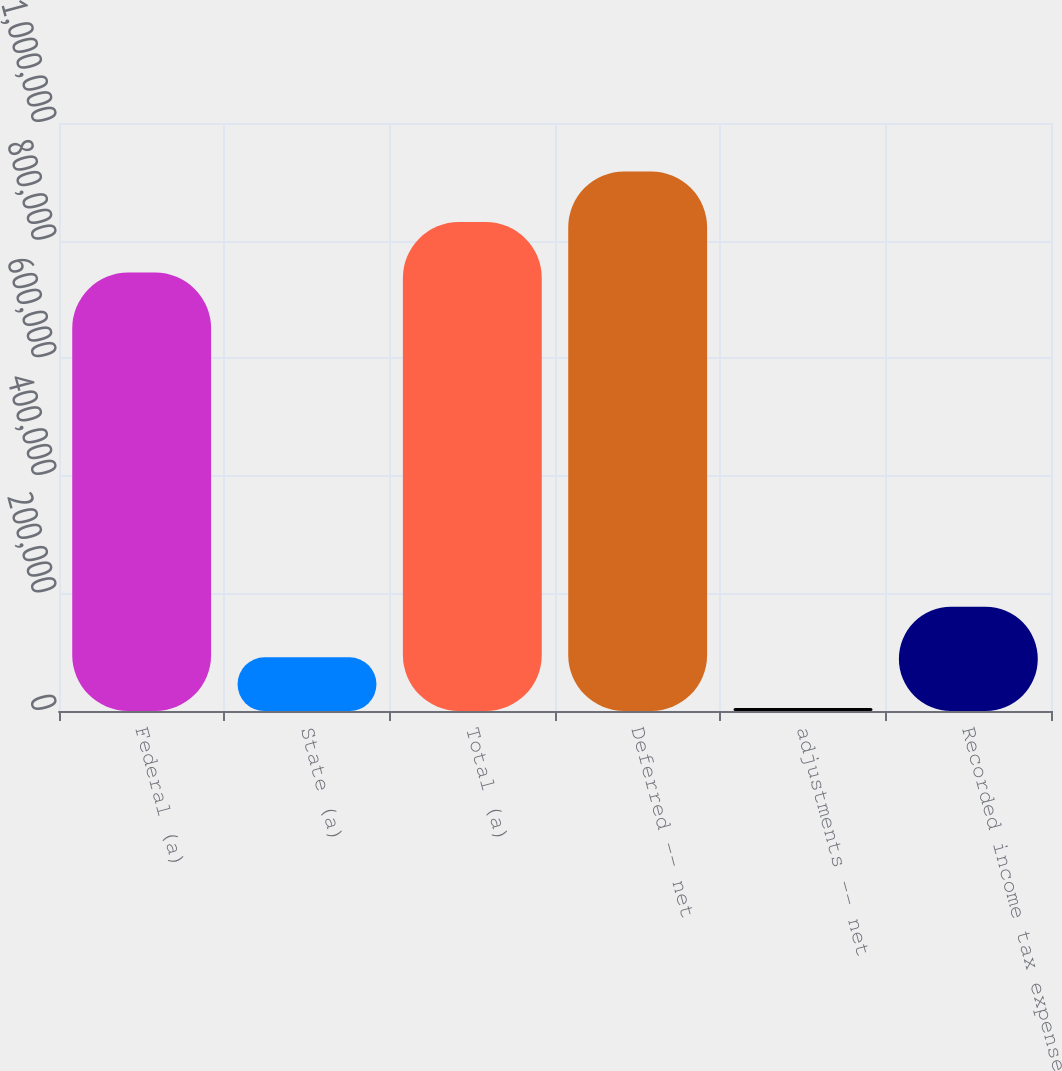<chart> <loc_0><loc_0><loc_500><loc_500><bar_chart><fcel>Federal (a)<fcel>State (a)<fcel>Total (a)<fcel>Deferred -- net<fcel>adjustments -- net<fcel>Recorded income tax expense<nl><fcel>745724<fcel>91218.5<fcel>831662<fcel>917599<fcel>5281<fcel>177156<nl></chart> 